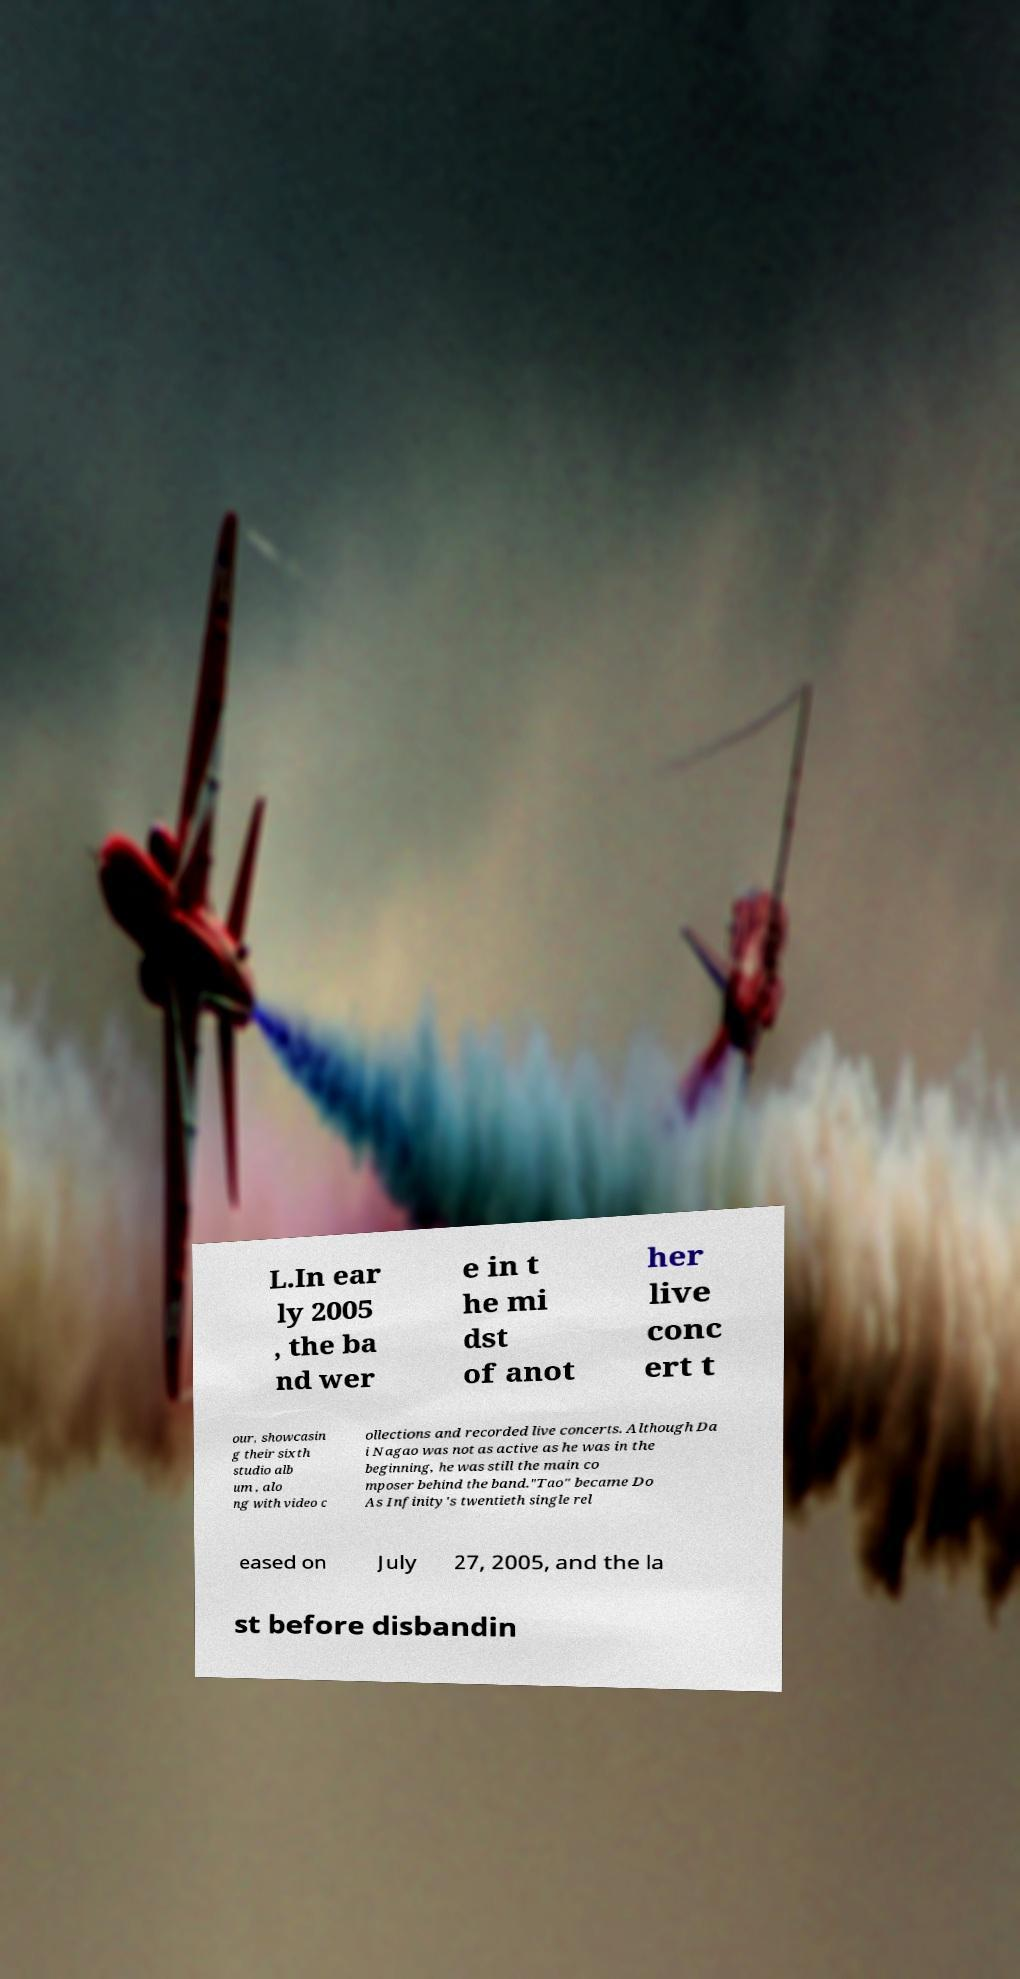There's text embedded in this image that I need extracted. Can you transcribe it verbatim? L.In ear ly 2005 , the ba nd wer e in t he mi dst of anot her live conc ert t our, showcasin g their sixth studio alb um , alo ng with video c ollections and recorded live concerts. Although Da i Nagao was not as active as he was in the beginning, he was still the main co mposer behind the band."Tao" became Do As Infinity's twentieth single rel eased on July 27, 2005, and the la st before disbandin 